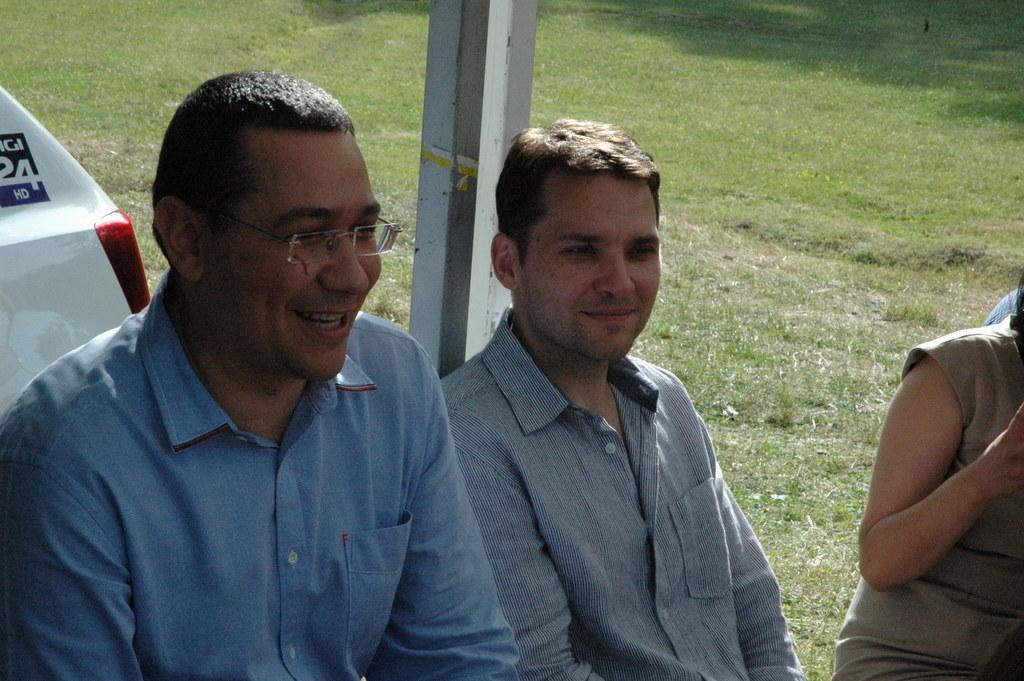Could you give a brief overview of what you see in this image? In this image we can see two persons sitting and on right side of the image we can see a lady person also sitting and in the background of the image there is pole, car and some grass. 